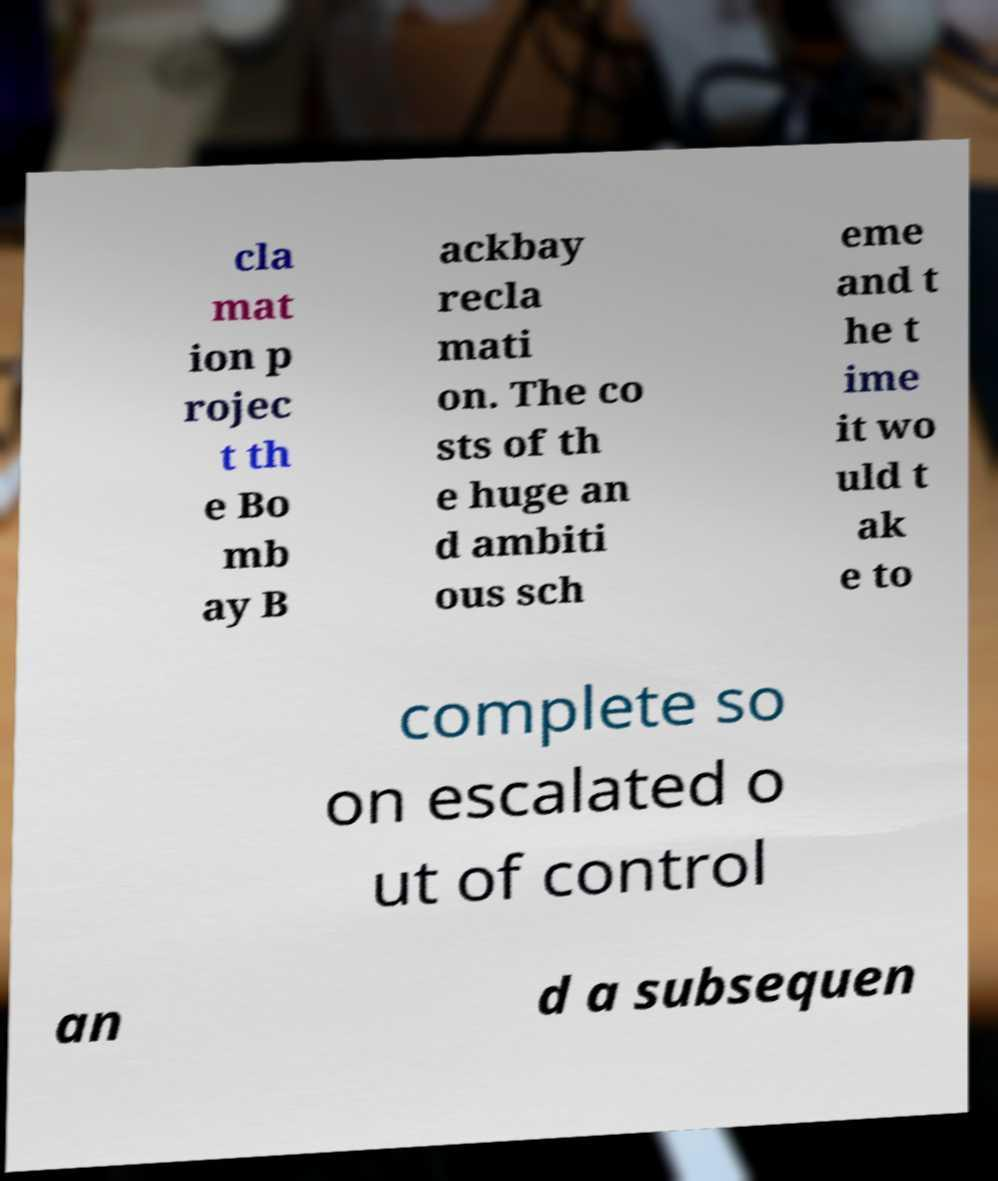Please identify and transcribe the text found in this image. cla mat ion p rojec t th e Bo mb ay B ackbay recla mati on. The co sts of th e huge an d ambiti ous sch eme and t he t ime it wo uld t ak e to complete so on escalated o ut of control an d a subsequen 